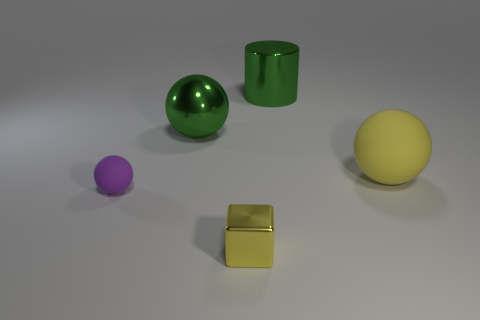Add 3 purple spheres. How many objects exist? 8 Subtract all cylinders. How many objects are left? 4 Add 3 matte things. How many matte things are left? 5 Add 4 small purple matte spheres. How many small purple matte spheres exist? 5 Subtract 1 yellow balls. How many objects are left? 4 Subtract all yellow matte balls. Subtract all tiny yellow things. How many objects are left? 3 